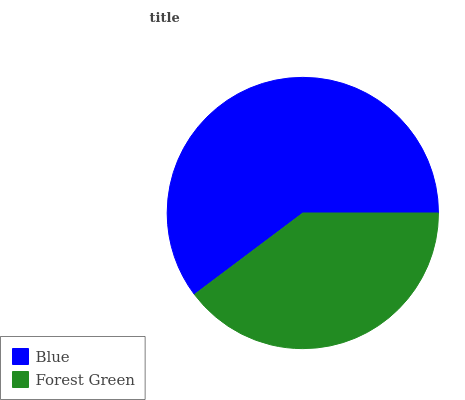Is Forest Green the minimum?
Answer yes or no. Yes. Is Blue the maximum?
Answer yes or no. Yes. Is Forest Green the maximum?
Answer yes or no. No. Is Blue greater than Forest Green?
Answer yes or no. Yes. Is Forest Green less than Blue?
Answer yes or no. Yes. Is Forest Green greater than Blue?
Answer yes or no. No. Is Blue less than Forest Green?
Answer yes or no. No. Is Blue the high median?
Answer yes or no. Yes. Is Forest Green the low median?
Answer yes or no. Yes. Is Forest Green the high median?
Answer yes or no. No. Is Blue the low median?
Answer yes or no. No. 